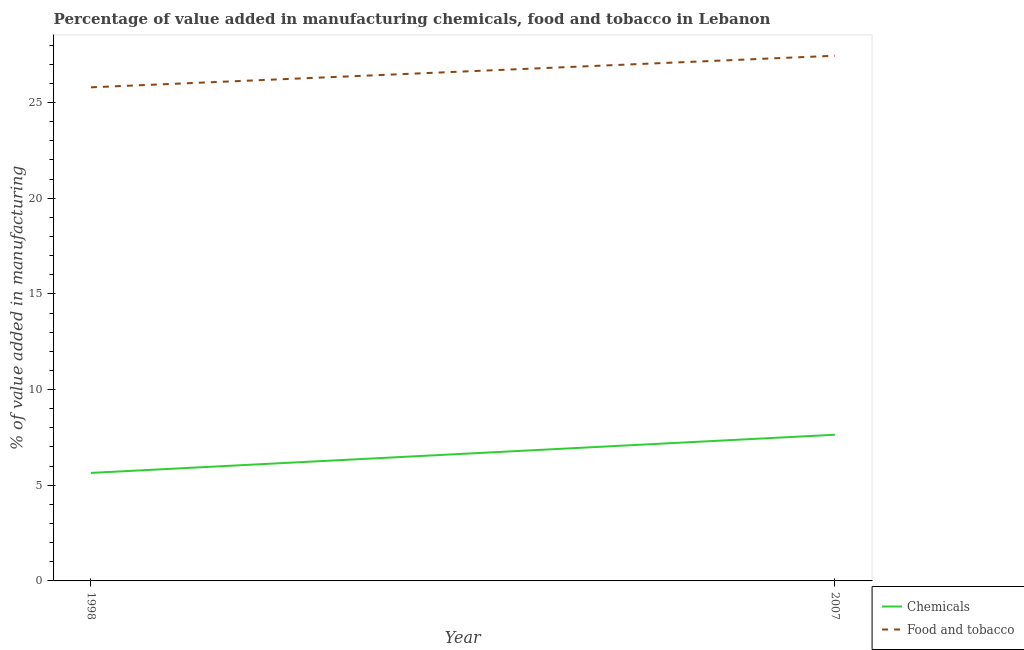How many different coloured lines are there?
Your answer should be very brief. 2. Does the line corresponding to value added by manufacturing food and tobacco intersect with the line corresponding to value added by  manufacturing chemicals?
Offer a very short reply. No. Is the number of lines equal to the number of legend labels?
Your answer should be very brief. Yes. What is the value added by  manufacturing chemicals in 1998?
Keep it short and to the point. 5.64. Across all years, what is the maximum value added by  manufacturing chemicals?
Ensure brevity in your answer.  7.64. Across all years, what is the minimum value added by  manufacturing chemicals?
Keep it short and to the point. 5.64. What is the total value added by manufacturing food and tobacco in the graph?
Give a very brief answer. 53.24. What is the difference between the value added by manufacturing food and tobacco in 1998 and that in 2007?
Give a very brief answer. -1.65. What is the difference between the value added by manufacturing food and tobacco in 2007 and the value added by  manufacturing chemicals in 1998?
Provide a succinct answer. 21.8. What is the average value added by manufacturing food and tobacco per year?
Your answer should be compact. 26.62. In the year 2007, what is the difference between the value added by  manufacturing chemicals and value added by manufacturing food and tobacco?
Your answer should be very brief. -19.81. What is the ratio of the value added by manufacturing food and tobacco in 1998 to that in 2007?
Make the answer very short. 0.94. Is the value added by manufacturing food and tobacco in 1998 less than that in 2007?
Provide a succinct answer. Yes. In how many years, is the value added by  manufacturing chemicals greater than the average value added by  manufacturing chemicals taken over all years?
Provide a short and direct response. 1. Does the value added by manufacturing food and tobacco monotonically increase over the years?
Provide a short and direct response. Yes. Is the value added by manufacturing food and tobacco strictly greater than the value added by  manufacturing chemicals over the years?
Your answer should be compact. Yes. How many lines are there?
Make the answer very short. 2. How many years are there in the graph?
Provide a succinct answer. 2. Are the values on the major ticks of Y-axis written in scientific E-notation?
Provide a short and direct response. No. Does the graph contain grids?
Offer a terse response. No. Where does the legend appear in the graph?
Offer a very short reply. Bottom right. What is the title of the graph?
Make the answer very short. Percentage of value added in manufacturing chemicals, food and tobacco in Lebanon. What is the label or title of the X-axis?
Offer a terse response. Year. What is the label or title of the Y-axis?
Your answer should be very brief. % of value added in manufacturing. What is the % of value added in manufacturing of Chemicals in 1998?
Keep it short and to the point. 5.64. What is the % of value added in manufacturing in Food and tobacco in 1998?
Keep it short and to the point. 25.79. What is the % of value added in manufacturing in Chemicals in 2007?
Offer a very short reply. 7.64. What is the % of value added in manufacturing of Food and tobacco in 2007?
Ensure brevity in your answer.  27.45. Across all years, what is the maximum % of value added in manufacturing of Chemicals?
Ensure brevity in your answer.  7.64. Across all years, what is the maximum % of value added in manufacturing in Food and tobacco?
Make the answer very short. 27.45. Across all years, what is the minimum % of value added in manufacturing of Chemicals?
Provide a succinct answer. 5.64. Across all years, what is the minimum % of value added in manufacturing of Food and tobacco?
Your answer should be very brief. 25.79. What is the total % of value added in manufacturing in Chemicals in the graph?
Your response must be concise. 13.28. What is the total % of value added in manufacturing of Food and tobacco in the graph?
Provide a short and direct response. 53.24. What is the difference between the % of value added in manufacturing in Chemicals in 1998 and that in 2007?
Provide a succinct answer. -1.99. What is the difference between the % of value added in manufacturing in Food and tobacco in 1998 and that in 2007?
Your response must be concise. -1.65. What is the difference between the % of value added in manufacturing in Chemicals in 1998 and the % of value added in manufacturing in Food and tobacco in 2007?
Provide a short and direct response. -21.8. What is the average % of value added in manufacturing in Chemicals per year?
Your answer should be compact. 6.64. What is the average % of value added in manufacturing in Food and tobacco per year?
Your answer should be compact. 26.62. In the year 1998, what is the difference between the % of value added in manufacturing in Chemicals and % of value added in manufacturing in Food and tobacco?
Make the answer very short. -20.15. In the year 2007, what is the difference between the % of value added in manufacturing in Chemicals and % of value added in manufacturing in Food and tobacco?
Keep it short and to the point. -19.81. What is the ratio of the % of value added in manufacturing of Chemicals in 1998 to that in 2007?
Make the answer very short. 0.74. What is the ratio of the % of value added in manufacturing in Food and tobacco in 1998 to that in 2007?
Keep it short and to the point. 0.94. What is the difference between the highest and the second highest % of value added in manufacturing in Chemicals?
Provide a succinct answer. 1.99. What is the difference between the highest and the second highest % of value added in manufacturing in Food and tobacco?
Give a very brief answer. 1.65. What is the difference between the highest and the lowest % of value added in manufacturing in Chemicals?
Provide a succinct answer. 1.99. What is the difference between the highest and the lowest % of value added in manufacturing of Food and tobacco?
Ensure brevity in your answer.  1.65. 